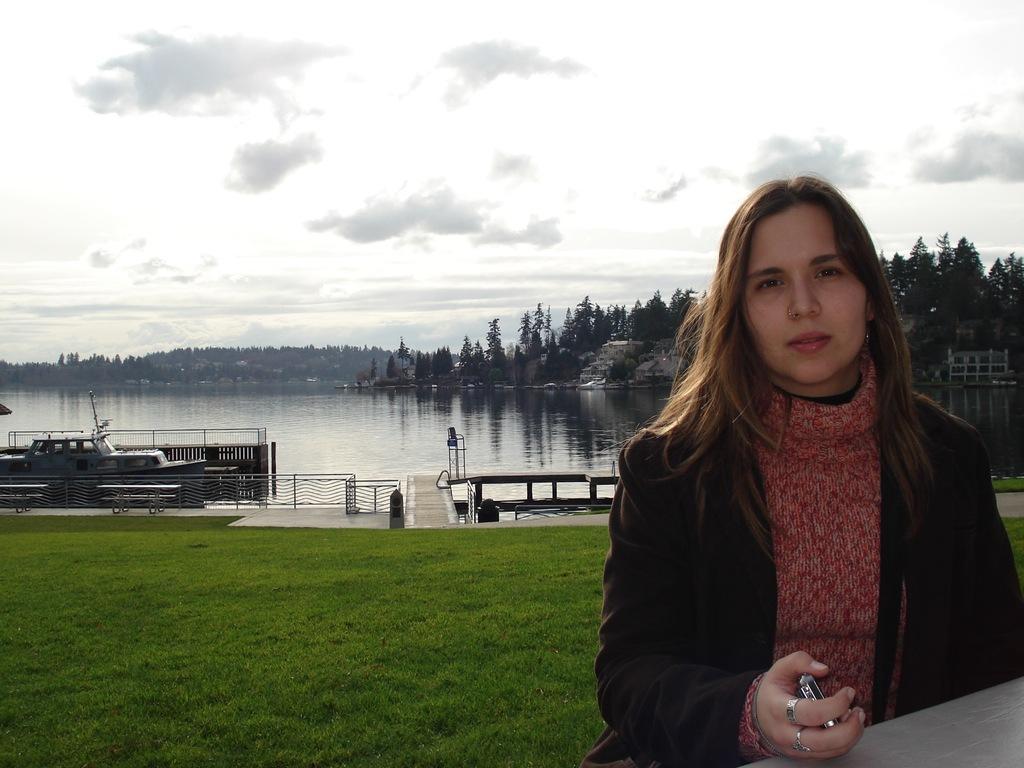In one or two sentences, can you explain what this image depicts? In this image there is a woman. She is holding an object. There is grass on the ground. There is a dock. There are benches and a railing. There is a vehicle parked at the railing. Behind the railing there is water. In the background there are mountains and trees. At the top there is the sky. 